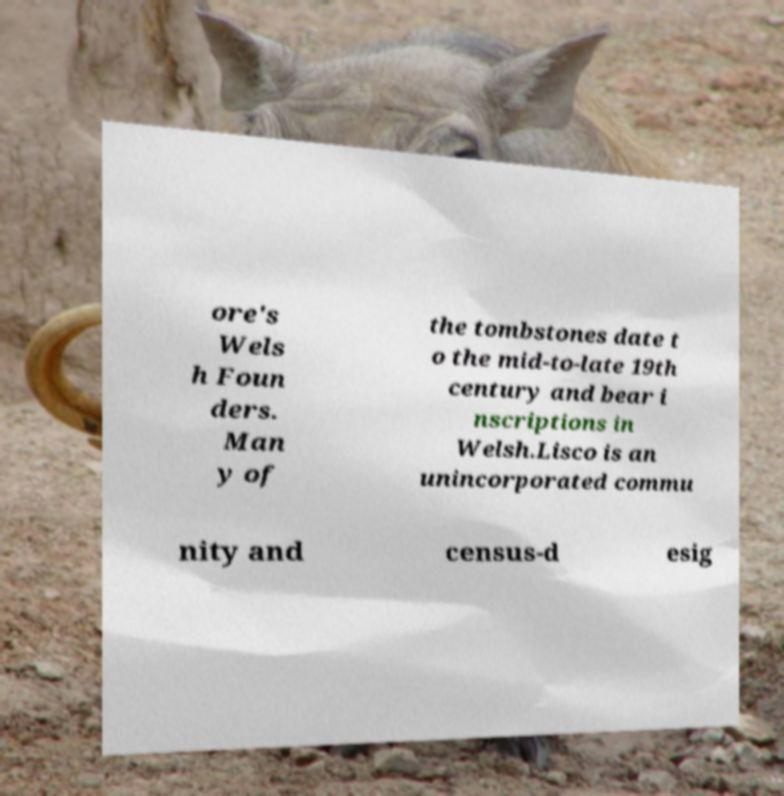There's text embedded in this image that I need extracted. Can you transcribe it verbatim? ore's Wels h Foun ders. Man y of the tombstones date t o the mid-to-late 19th century and bear i nscriptions in Welsh.Lisco is an unincorporated commu nity and census-d esig 